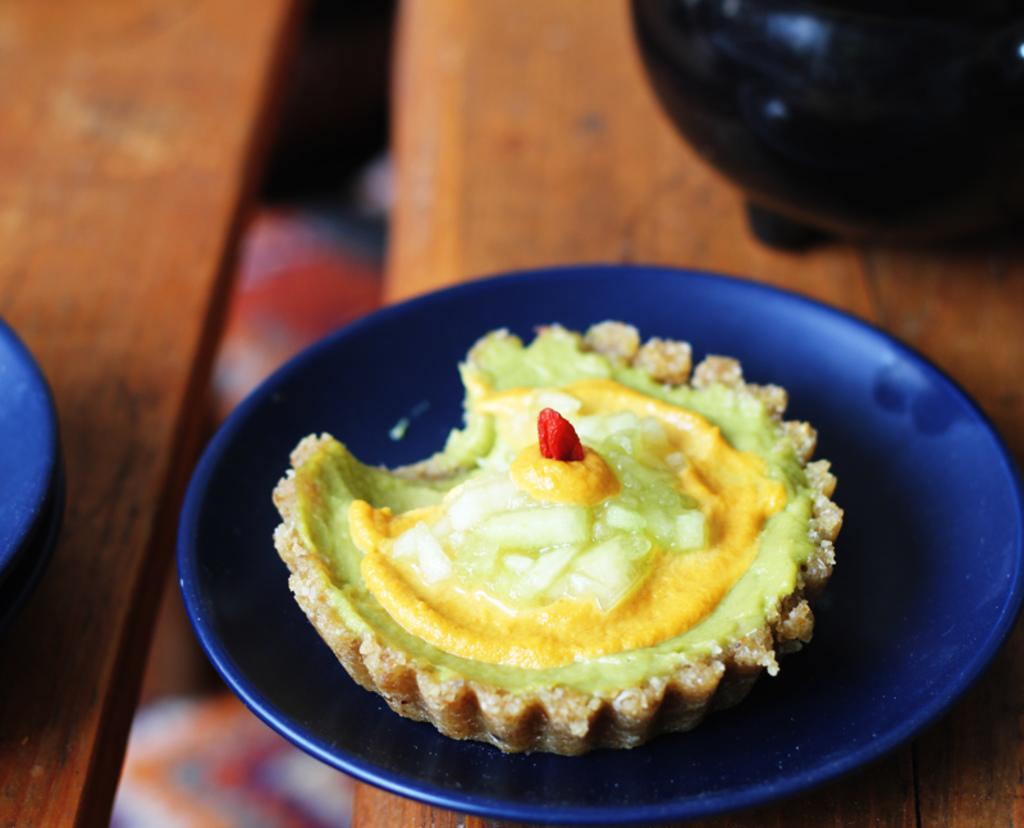Please provide a concise description of this image. On a platform we can see food in a blue plate and we can see other objects. 